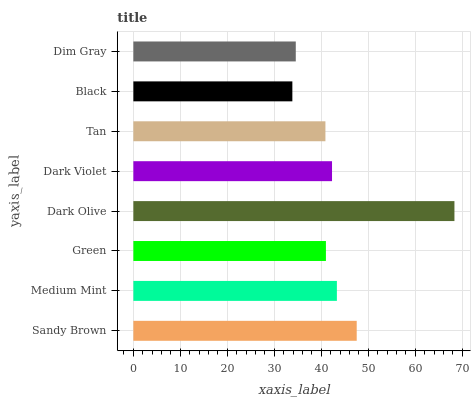Is Black the minimum?
Answer yes or no. Yes. Is Dark Olive the maximum?
Answer yes or no. Yes. Is Medium Mint the minimum?
Answer yes or no. No. Is Medium Mint the maximum?
Answer yes or no. No. Is Sandy Brown greater than Medium Mint?
Answer yes or no. Yes. Is Medium Mint less than Sandy Brown?
Answer yes or no. Yes. Is Medium Mint greater than Sandy Brown?
Answer yes or no. No. Is Sandy Brown less than Medium Mint?
Answer yes or no. No. Is Dark Violet the high median?
Answer yes or no. Yes. Is Green the low median?
Answer yes or no. Yes. Is Tan the high median?
Answer yes or no. No. Is Dim Gray the low median?
Answer yes or no. No. 